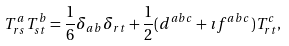<formula> <loc_0><loc_0><loc_500><loc_500>T ^ { a } _ { r s } T ^ { b } _ { s t } = \frac { 1 } { 6 } \delta _ { a b } \delta _ { r t } + \frac { 1 } { 2 } ( d ^ { a b c } + \imath f ^ { a b c } ) T ^ { c } _ { r t } ,</formula> 